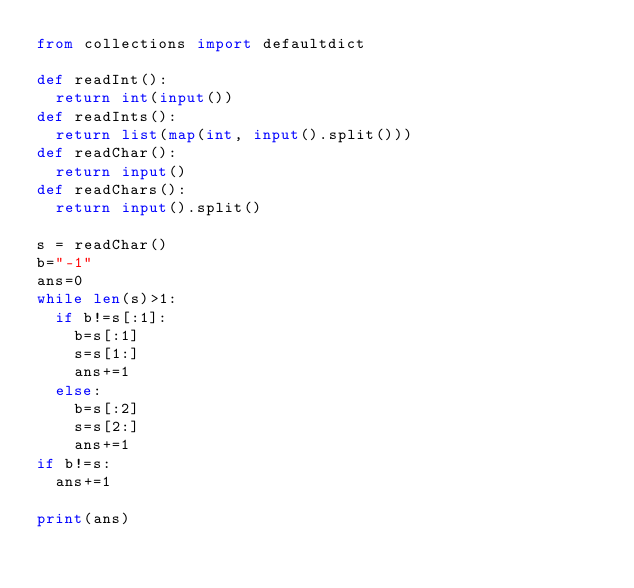<code> <loc_0><loc_0><loc_500><loc_500><_Python_>from collections import defaultdict

def readInt():
	return int(input())
def readInts():
	return list(map(int, input().split()))
def readChar():
	return input()
def readChars():
	return input().split()

s = readChar()
b="-1"
ans=0
while len(s)>1:
	if b!=s[:1]:
		b=s[:1]
		s=s[1:]
		ans+=1
	else:
		b=s[:2]
		s=s[2:]
		ans+=1
if b!=s:
	ans+=1

print(ans)</code> 